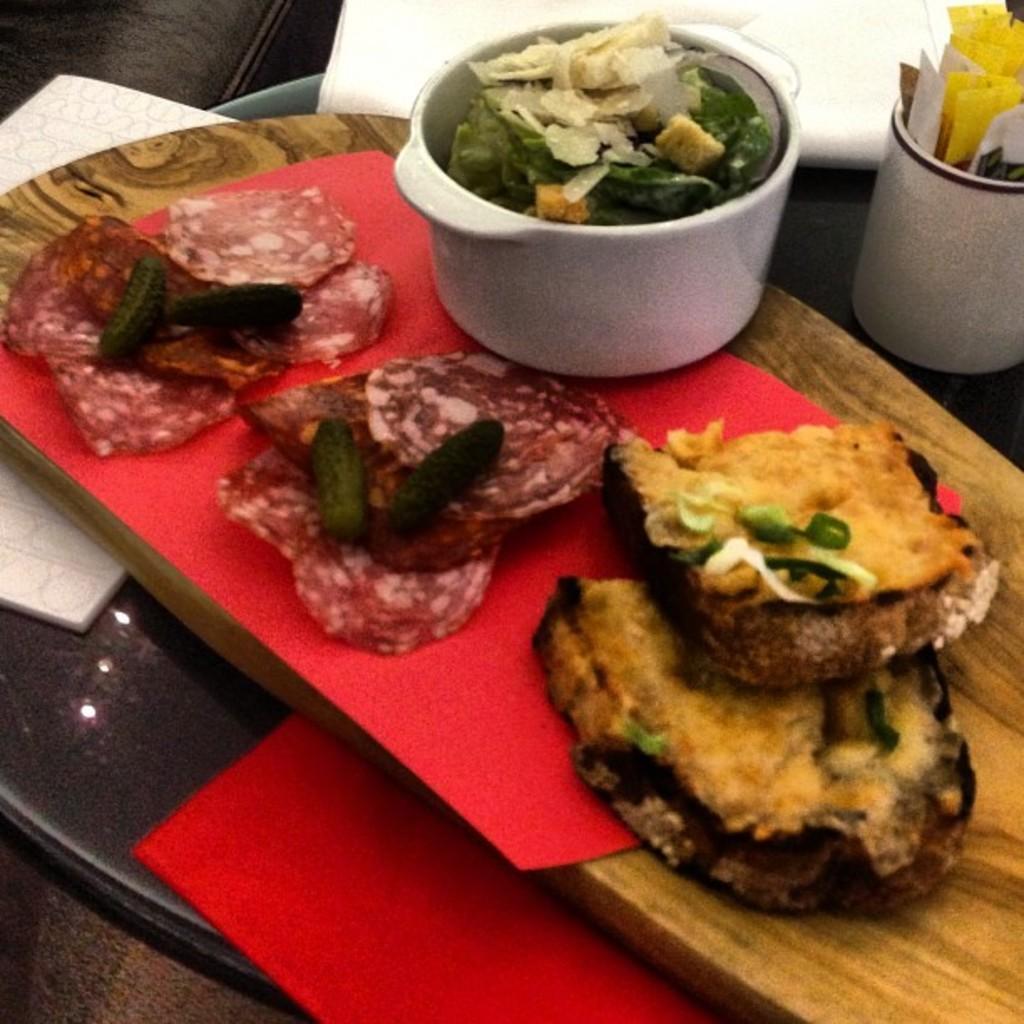Describe this image in one or two sentences. In the image there is a tray with white paper and red cloth. On that there is a wooden tray with food items and also there is a bowl with food item in it. On the right corner of the image there is a cup with few items in it. 